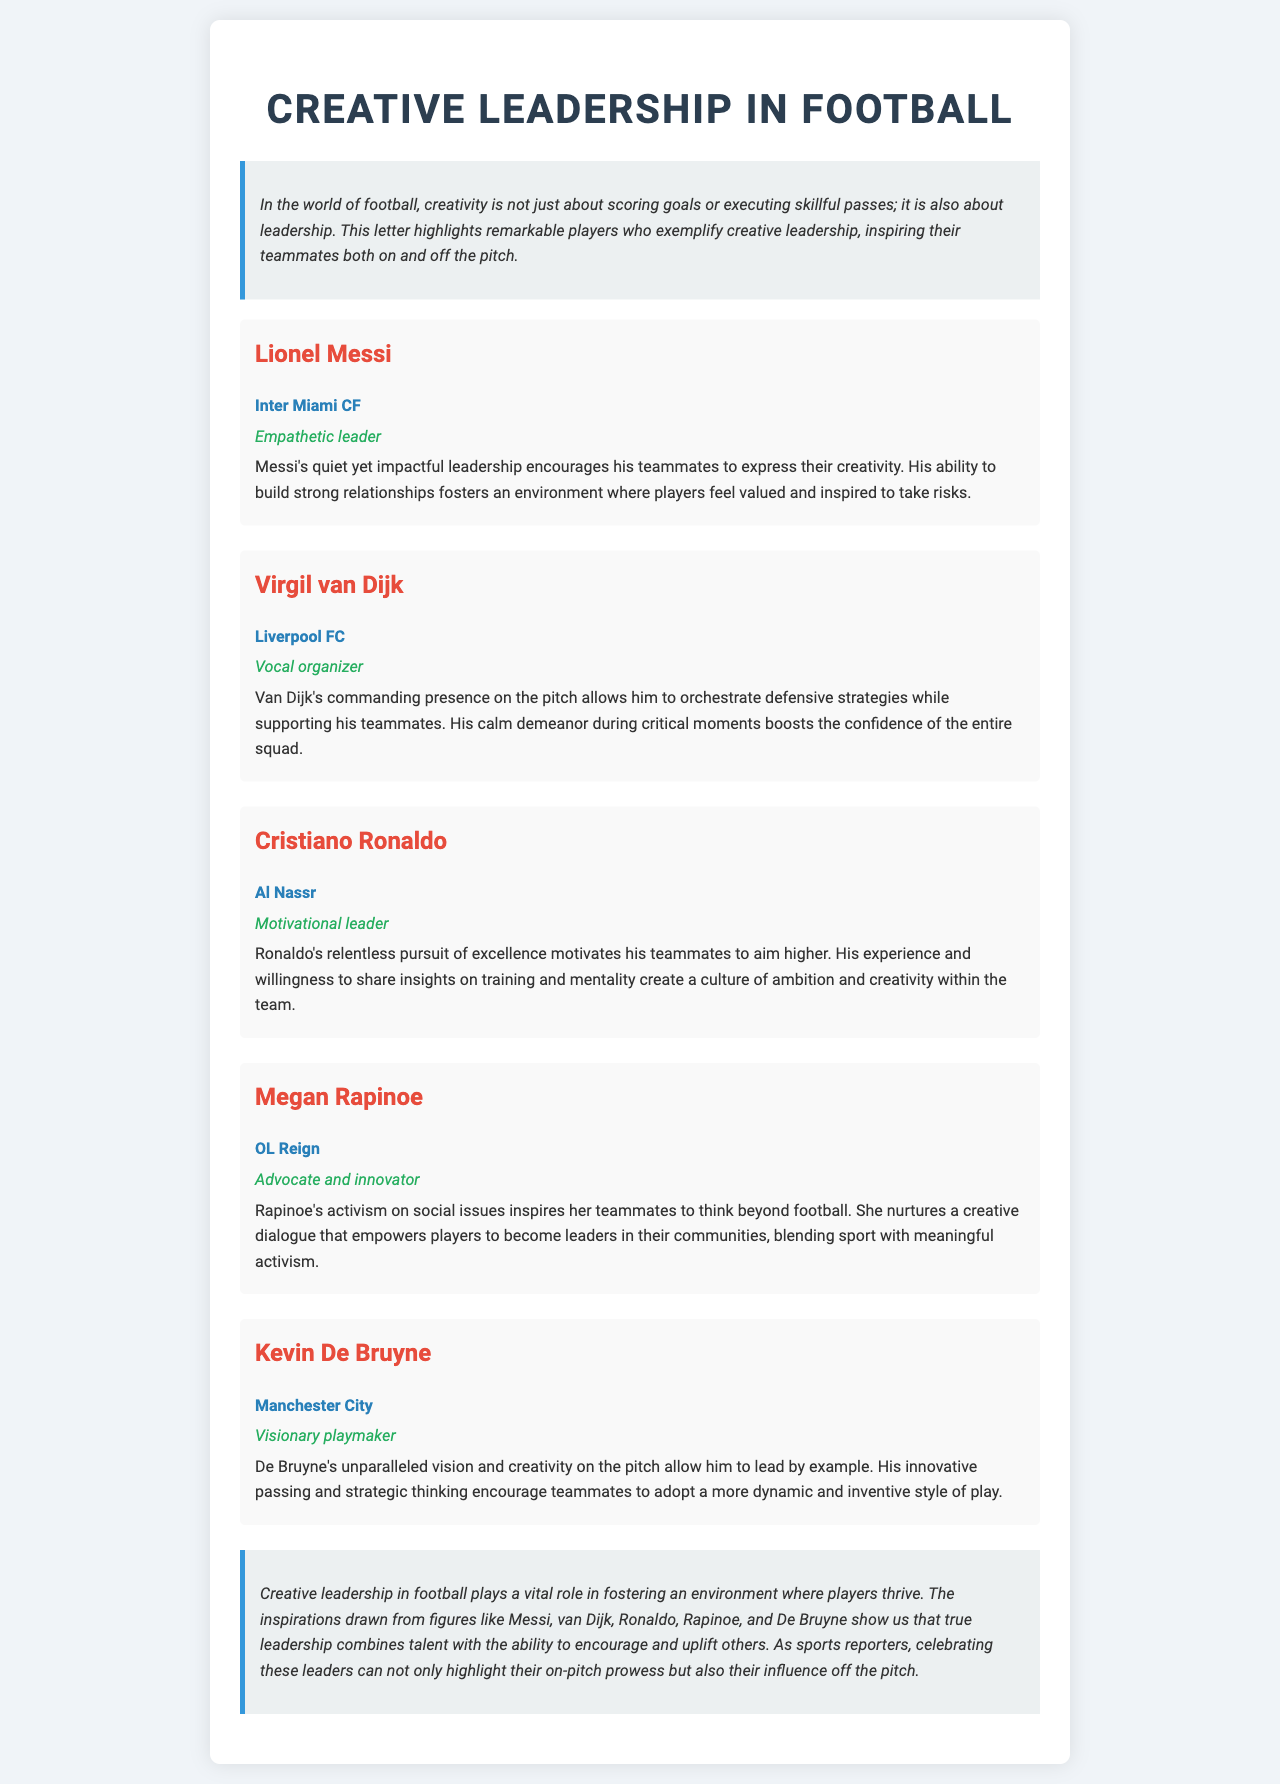What is the title of the document? The title is displayed prominently at the top of the letter, indicating the main focus of the content.
Answer: Creative Leadership in Football Which player is listed as an "Empathetic leader"? The document describes Lionel Messi as an empathetic leader in his player section.
Answer: Lionel Messi What club does Megan Rapinoe play for? The club information is provided in the section dedicated to each player, detailing their current teams.
Answer: OL Reign How does Kevin De Bruyne's leadership style get characterized? The section on Kevin De Bruyne provides insight into his style of leadership and how it impacts the team.
Answer: Visionary playmaker What is the main theme of the document? The introduction establishes the overarching theme that creativity in leadership is essential for success in football.
Answer: Creative leadership Who is identified as an advocate and innovator among the players? The document specifically mentions Megan Rapinoe as someone who blends activism with her role in football.
Answer: Megan Rapinoe What does Cristiano Ronaldo encourage in his teammates? The description in Ronaldo's section highlights the motivational aspect of his leadership and what he inspires in his peers.
Answer: Aim higher How does Virgil van Dijk contribute to his team's confidence? The document explains van Dijk's impact on team morale and confidence through his demeanor.
Answer: Calm demeanor 